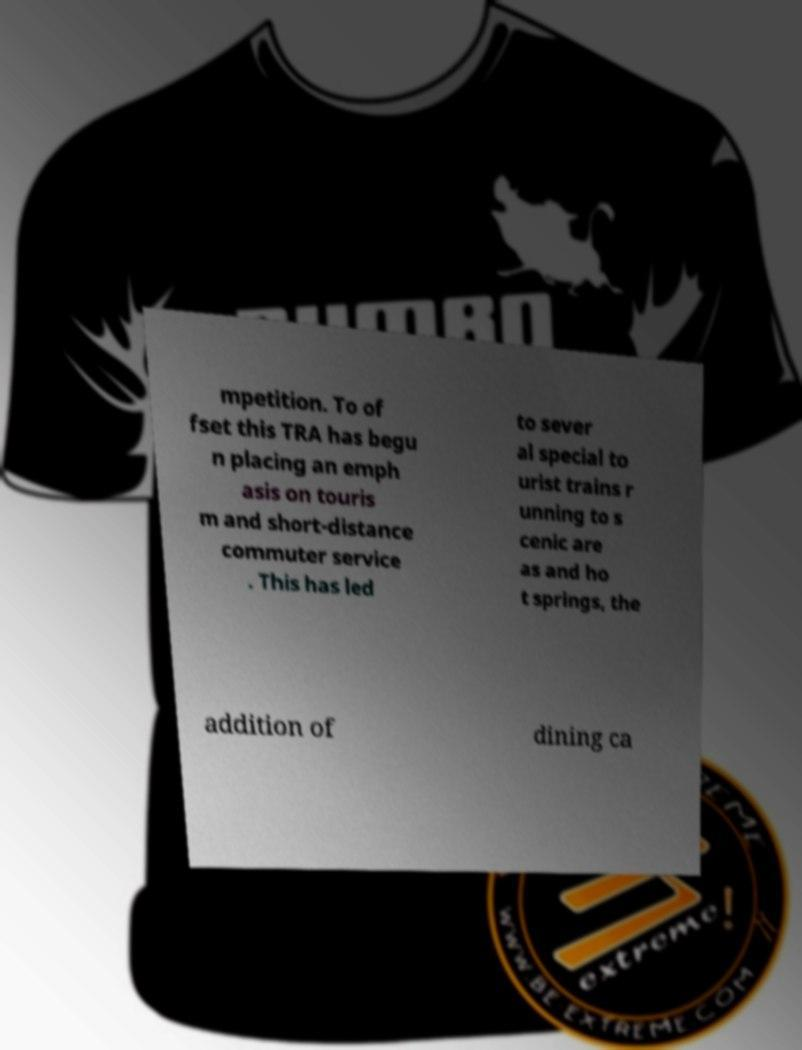I need the written content from this picture converted into text. Can you do that? mpetition. To of fset this TRA has begu n placing an emph asis on touris m and short-distance commuter service . This has led to sever al special to urist trains r unning to s cenic are as and ho t springs, the addition of dining ca 